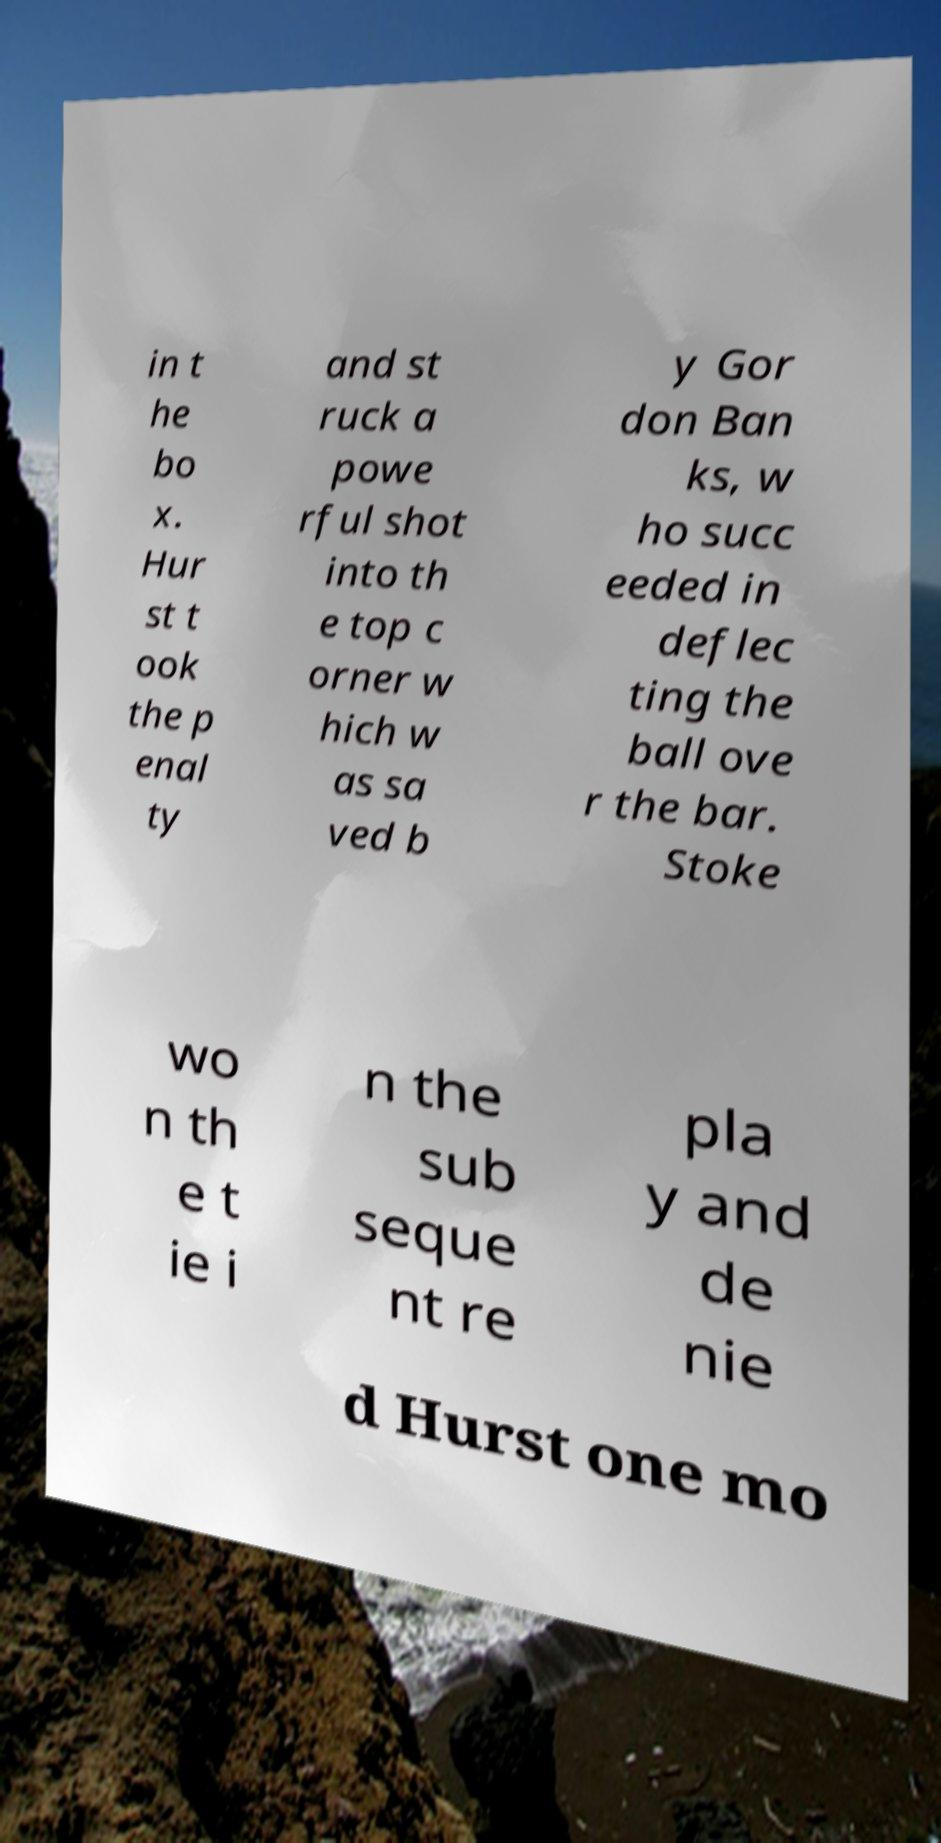Could you extract and type out the text from this image? in t he bo x. Hur st t ook the p enal ty and st ruck a powe rful shot into th e top c orner w hich w as sa ved b y Gor don Ban ks, w ho succ eeded in deflec ting the ball ove r the bar. Stoke wo n th e t ie i n the sub seque nt re pla y and de nie d Hurst one mo 